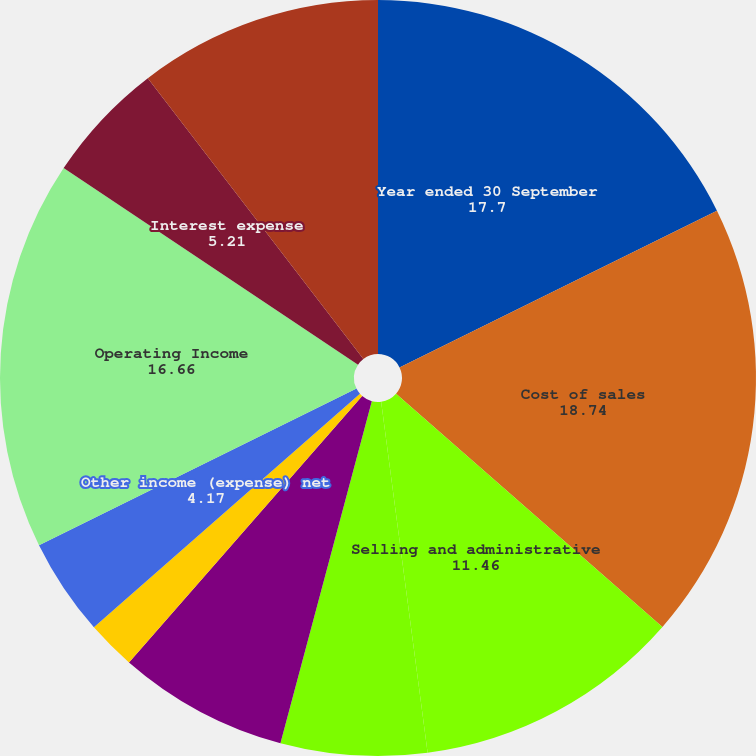Convert chart. <chart><loc_0><loc_0><loc_500><loc_500><pie_chart><fcel>Year ended 30 September<fcel>Cost of sales<fcel>Selling and administrative<fcel>Research and development<fcel>Business restructuring and<fcel>Pension settlement loss<fcel>Other income (expense) net<fcel>Operating Income<fcel>Interest expense<fcel>Income tax provision<nl><fcel>17.7%<fcel>18.74%<fcel>11.46%<fcel>6.25%<fcel>7.29%<fcel>2.09%<fcel>4.17%<fcel>16.66%<fcel>5.21%<fcel>10.42%<nl></chart> 